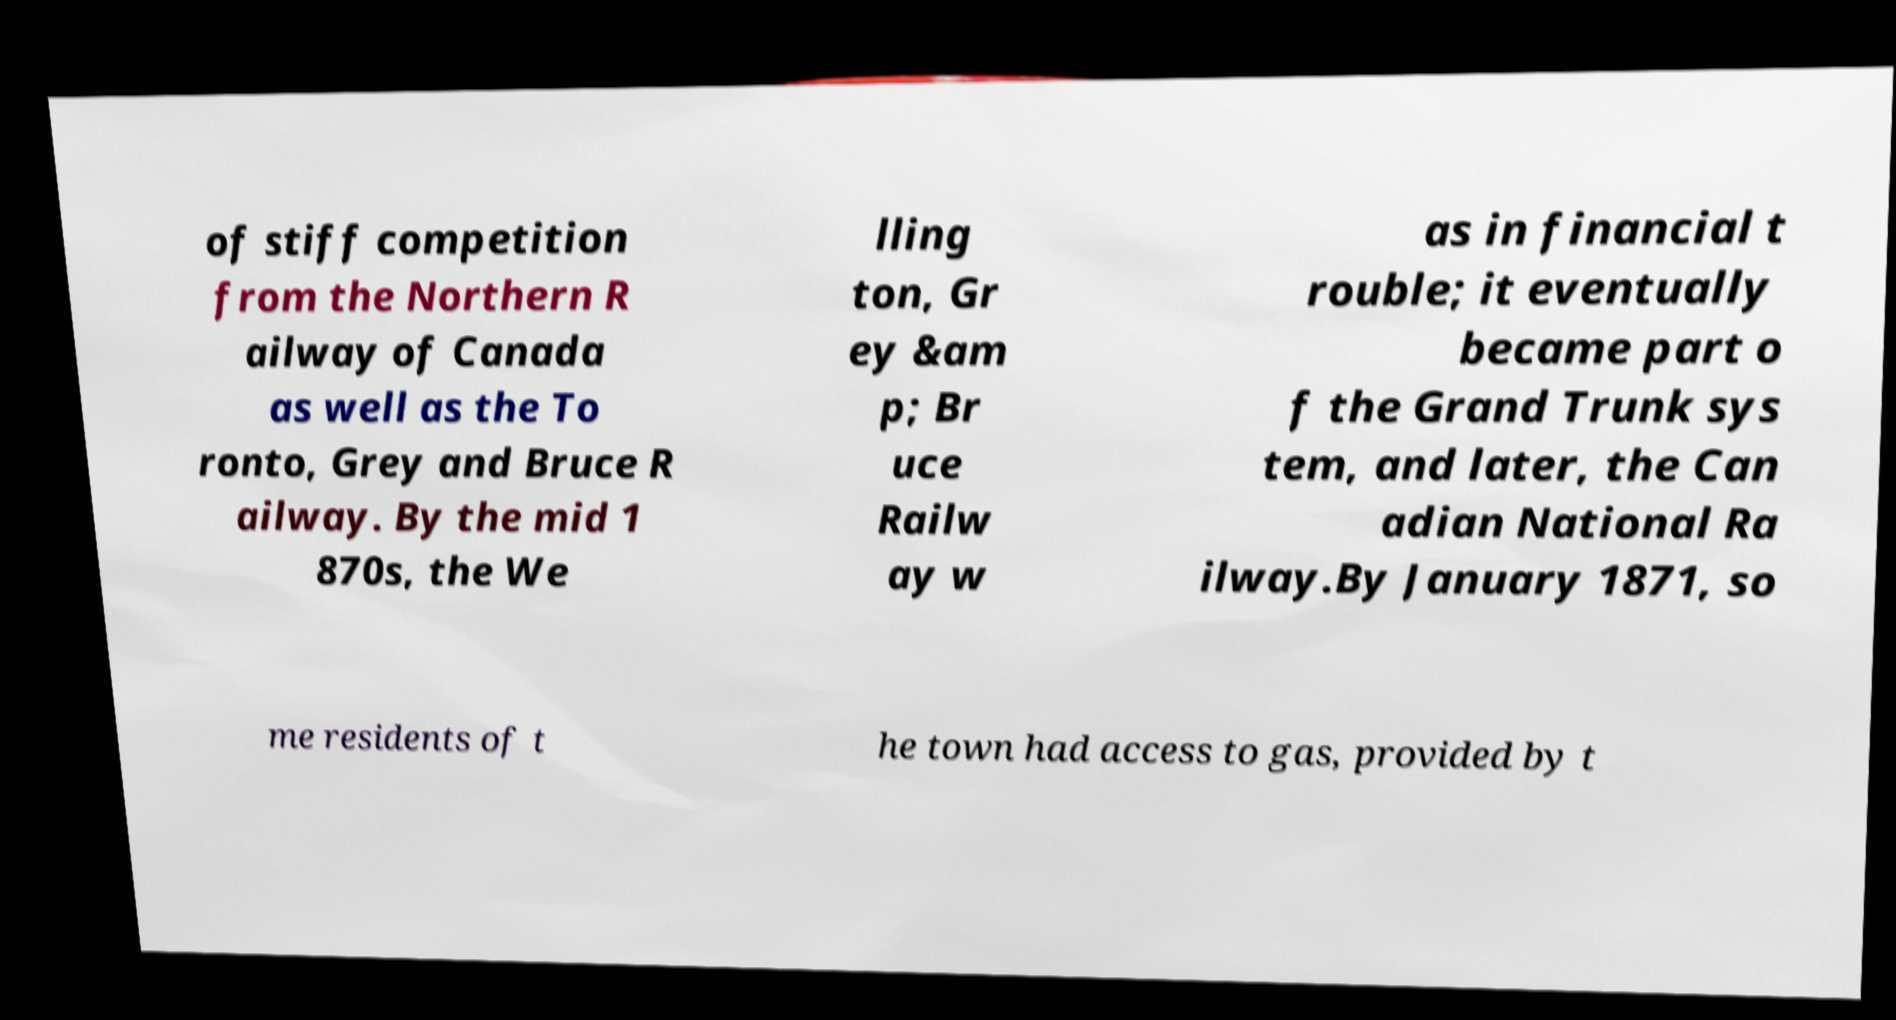Could you assist in decoding the text presented in this image and type it out clearly? of stiff competition from the Northern R ailway of Canada as well as the To ronto, Grey and Bruce R ailway. By the mid 1 870s, the We lling ton, Gr ey &am p; Br uce Railw ay w as in financial t rouble; it eventually became part o f the Grand Trunk sys tem, and later, the Can adian National Ra ilway.By January 1871, so me residents of t he town had access to gas, provided by t 